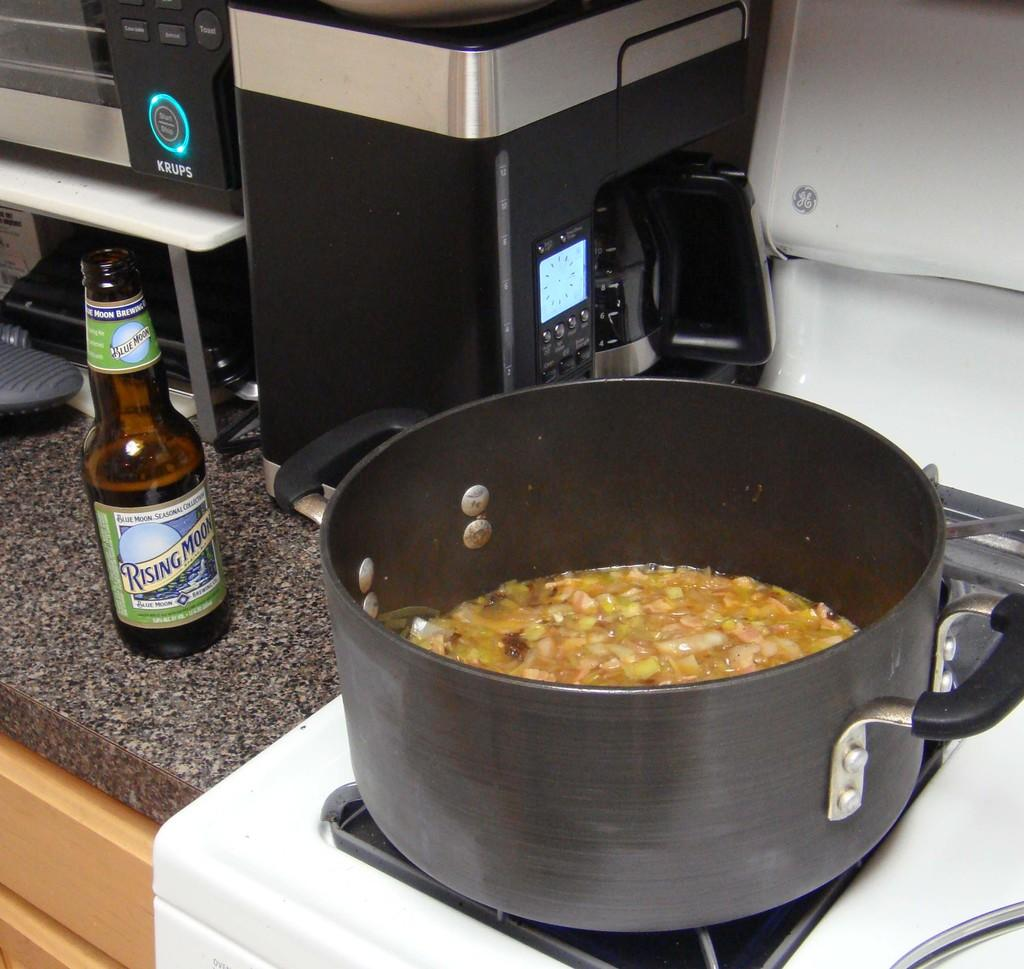<image>
Describe the image concisely. A glass Rising Moon beer bottle sits next to a boiling pot. 